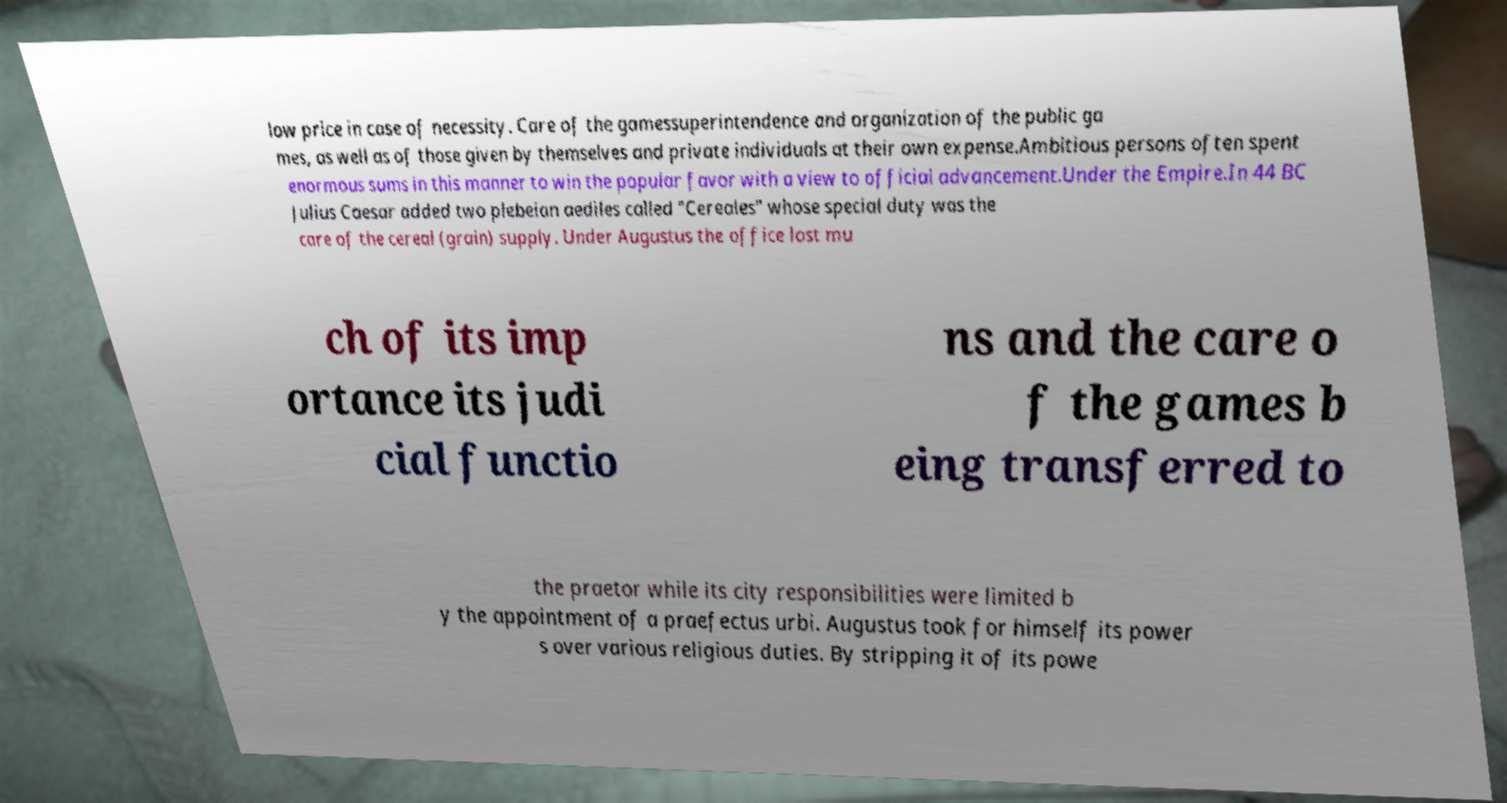Can you read and provide the text displayed in the image?This photo seems to have some interesting text. Can you extract and type it out for me? low price in case of necessity. Care of the gamessuperintendence and organization of the public ga mes, as well as of those given by themselves and private individuals at their own expense.Ambitious persons often spent enormous sums in this manner to win the popular favor with a view to official advancement.Under the Empire.In 44 BC Julius Caesar added two plebeian aediles called "Cereales" whose special duty was the care of the cereal (grain) supply. Under Augustus the office lost mu ch of its imp ortance its judi cial functio ns and the care o f the games b eing transferred to the praetor while its city responsibilities were limited b y the appointment of a praefectus urbi. Augustus took for himself its power s over various religious duties. By stripping it of its powe 